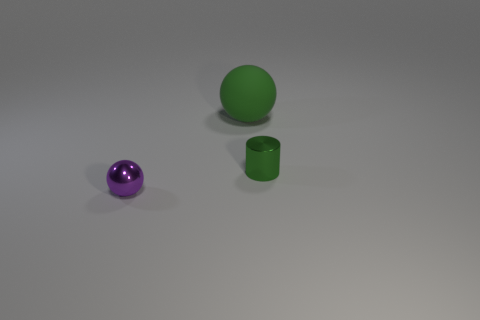How many other objects are there of the same material as the large green ball?
Your response must be concise. 0. What number of things are green objects on the right side of the big green sphere or gray metallic balls?
Make the answer very short. 1. The object that is on the left side of the green thing behind the green cylinder is what shape?
Ensure brevity in your answer.  Sphere. There is a tiny thing on the right side of the tiny ball; is it the same shape as the green rubber thing?
Offer a very short reply. No. What color is the ball that is behind the green metallic thing?
Offer a terse response. Green. What number of blocks are blue metallic things or small metal things?
Keep it short and to the point. 0. There is a shiny thing that is left of the small object right of the large thing; what size is it?
Keep it short and to the point. Small. There is a rubber thing; does it have the same color as the ball in front of the big green ball?
Provide a succinct answer. No. There is a large matte object; what number of big green rubber objects are in front of it?
Give a very brief answer. 0. Is the number of tiny shiny objects less than the number of green shiny cubes?
Ensure brevity in your answer.  No. 